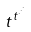Convert formula to latex. <formula><loc_0><loc_0><loc_500><loc_500>t ^ { t ^ { \cdot ^ { \cdot ^ { \cdot } } } }</formula> 